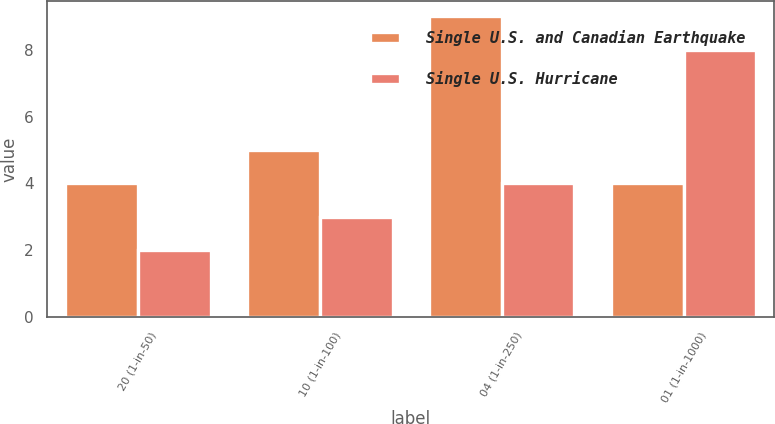Convert chart. <chart><loc_0><loc_0><loc_500><loc_500><stacked_bar_chart><ecel><fcel>20 (1-in-50)<fcel>10 (1-in-100)<fcel>04 (1-in-250)<fcel>01 (1-in-1000)<nl><fcel>Single U.S. and Canadian Earthquake<fcel>4<fcel>5<fcel>9<fcel>4<nl><fcel>Single U.S. Hurricane<fcel>2<fcel>3<fcel>4<fcel>8<nl></chart> 